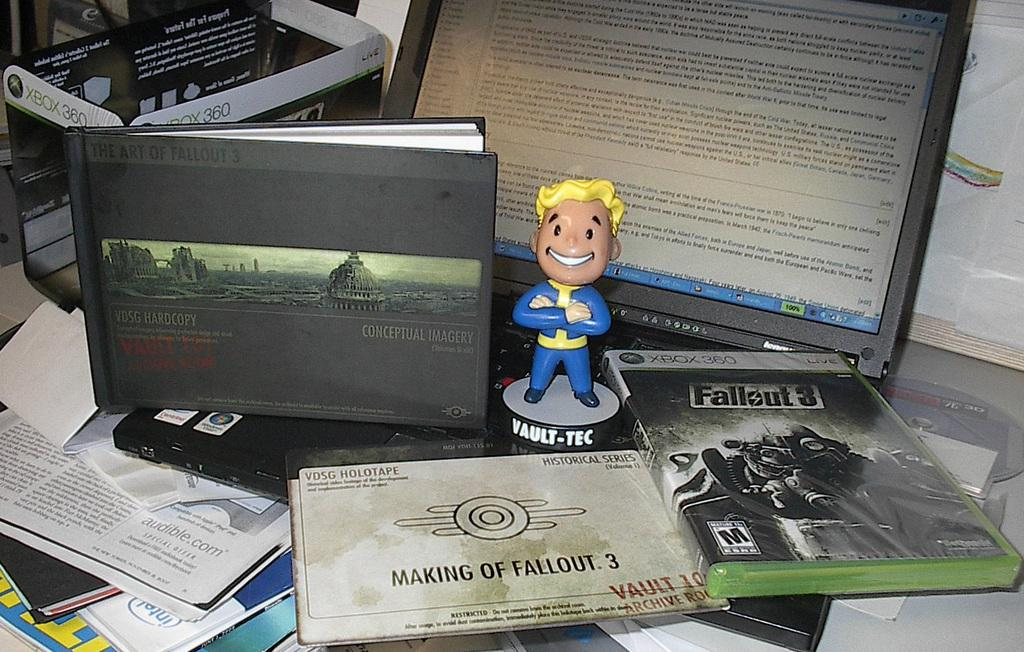<image>
Give a short and clear explanation of the subsequent image. A small figurine of a super hero reading  VAULT-TEC on the base. 